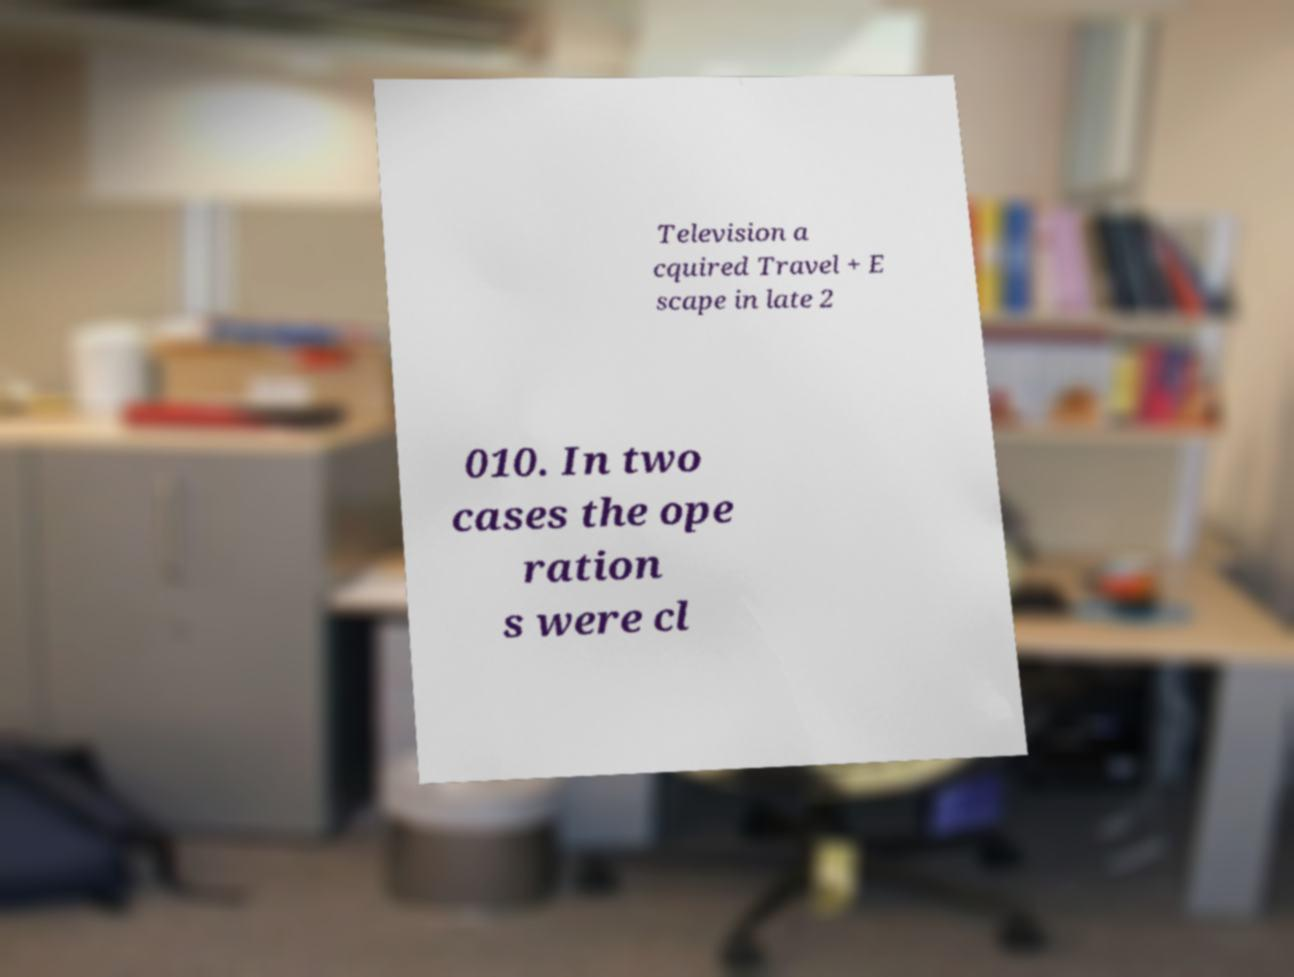Please identify and transcribe the text found in this image. Television a cquired Travel + E scape in late 2 010. In two cases the ope ration s were cl 